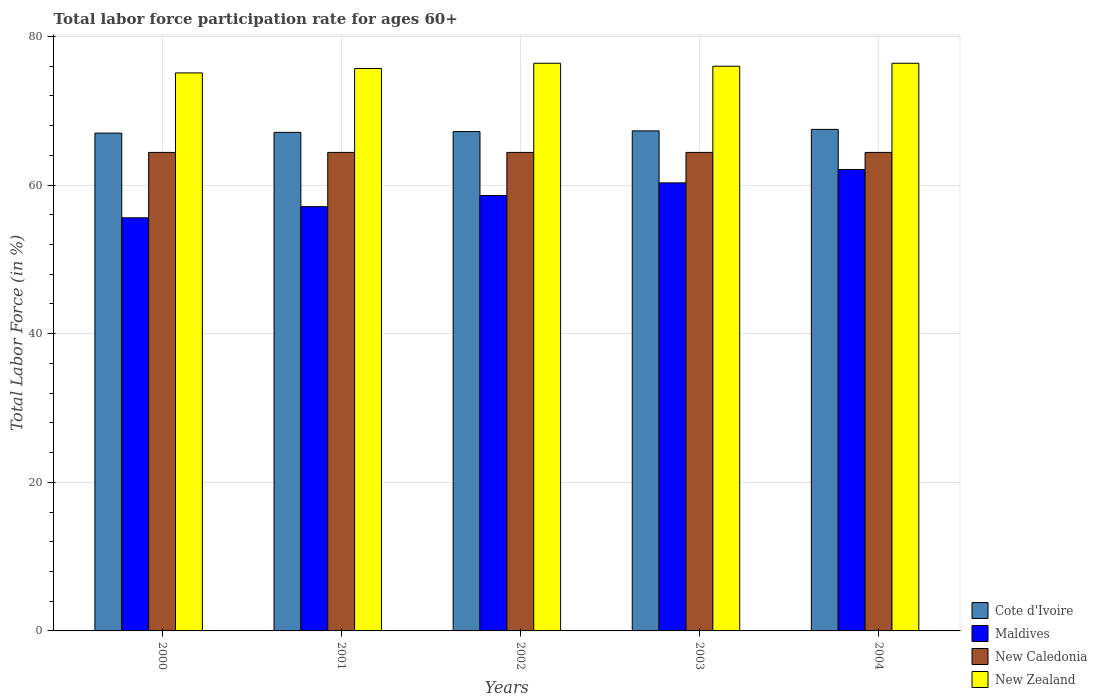Are the number of bars on each tick of the X-axis equal?
Ensure brevity in your answer.  Yes. How many bars are there on the 3rd tick from the left?
Offer a very short reply. 4. How many bars are there on the 1st tick from the right?
Offer a terse response. 4. In how many cases, is the number of bars for a given year not equal to the number of legend labels?
Provide a short and direct response. 0. What is the labor force participation rate in Cote d'Ivoire in 2004?
Offer a terse response. 67.5. Across all years, what is the maximum labor force participation rate in Cote d'Ivoire?
Your response must be concise. 67.5. Across all years, what is the minimum labor force participation rate in New Zealand?
Provide a short and direct response. 75.1. In which year was the labor force participation rate in New Zealand minimum?
Make the answer very short. 2000. What is the total labor force participation rate in Cote d'Ivoire in the graph?
Offer a very short reply. 336.1. What is the difference between the labor force participation rate in Cote d'Ivoire in 2000 and that in 2004?
Ensure brevity in your answer.  -0.5. What is the difference between the labor force participation rate in New Zealand in 2000 and the labor force participation rate in Maldives in 2003?
Make the answer very short. 14.8. What is the average labor force participation rate in Cote d'Ivoire per year?
Make the answer very short. 67.22. In the year 2002, what is the difference between the labor force participation rate in Maldives and labor force participation rate in New Zealand?
Offer a terse response. -17.8. In how many years, is the labor force participation rate in Maldives greater than 28 %?
Offer a very short reply. 5. What is the ratio of the labor force participation rate in Maldives in 2000 to that in 2004?
Provide a succinct answer. 0.9. Is the labor force participation rate in Cote d'Ivoire in 2001 less than that in 2004?
Offer a very short reply. Yes. Is the difference between the labor force participation rate in Maldives in 2000 and 2003 greater than the difference between the labor force participation rate in New Zealand in 2000 and 2003?
Provide a short and direct response. No. What is the difference between the highest and the second highest labor force participation rate in New Zealand?
Keep it short and to the point. 0. What is the difference between the highest and the lowest labor force participation rate in Maldives?
Your answer should be very brief. 6.5. In how many years, is the labor force participation rate in Cote d'Ivoire greater than the average labor force participation rate in Cote d'Ivoire taken over all years?
Ensure brevity in your answer.  2. Is it the case that in every year, the sum of the labor force participation rate in New Caledonia and labor force participation rate in Cote d'Ivoire is greater than the sum of labor force participation rate in Maldives and labor force participation rate in New Zealand?
Provide a short and direct response. No. What does the 2nd bar from the left in 2001 represents?
Provide a short and direct response. Maldives. What does the 2nd bar from the right in 2000 represents?
Your response must be concise. New Caledonia. Is it the case that in every year, the sum of the labor force participation rate in Maldives and labor force participation rate in New Caledonia is greater than the labor force participation rate in Cote d'Ivoire?
Your response must be concise. Yes. Are all the bars in the graph horizontal?
Your answer should be compact. No. How many years are there in the graph?
Your answer should be compact. 5. Does the graph contain any zero values?
Make the answer very short. No. Where does the legend appear in the graph?
Make the answer very short. Bottom right. How many legend labels are there?
Offer a terse response. 4. What is the title of the graph?
Your answer should be very brief. Total labor force participation rate for ages 60+. What is the label or title of the X-axis?
Make the answer very short. Years. What is the label or title of the Y-axis?
Make the answer very short. Total Labor Force (in %). What is the Total Labor Force (in %) in Maldives in 2000?
Give a very brief answer. 55.6. What is the Total Labor Force (in %) in New Caledonia in 2000?
Make the answer very short. 64.4. What is the Total Labor Force (in %) in New Zealand in 2000?
Make the answer very short. 75.1. What is the Total Labor Force (in %) of Cote d'Ivoire in 2001?
Offer a very short reply. 67.1. What is the Total Labor Force (in %) in Maldives in 2001?
Make the answer very short. 57.1. What is the Total Labor Force (in %) in New Caledonia in 2001?
Keep it short and to the point. 64.4. What is the Total Labor Force (in %) in New Zealand in 2001?
Make the answer very short. 75.7. What is the Total Labor Force (in %) in Cote d'Ivoire in 2002?
Your answer should be compact. 67.2. What is the Total Labor Force (in %) of Maldives in 2002?
Your answer should be very brief. 58.6. What is the Total Labor Force (in %) of New Caledonia in 2002?
Provide a short and direct response. 64.4. What is the Total Labor Force (in %) of New Zealand in 2002?
Your answer should be compact. 76.4. What is the Total Labor Force (in %) of Cote d'Ivoire in 2003?
Your answer should be compact. 67.3. What is the Total Labor Force (in %) of Maldives in 2003?
Keep it short and to the point. 60.3. What is the Total Labor Force (in %) in New Caledonia in 2003?
Offer a terse response. 64.4. What is the Total Labor Force (in %) of Cote d'Ivoire in 2004?
Offer a very short reply. 67.5. What is the Total Labor Force (in %) of Maldives in 2004?
Your response must be concise. 62.1. What is the Total Labor Force (in %) of New Caledonia in 2004?
Keep it short and to the point. 64.4. What is the Total Labor Force (in %) of New Zealand in 2004?
Your response must be concise. 76.4. Across all years, what is the maximum Total Labor Force (in %) in Cote d'Ivoire?
Your response must be concise. 67.5. Across all years, what is the maximum Total Labor Force (in %) of Maldives?
Offer a very short reply. 62.1. Across all years, what is the maximum Total Labor Force (in %) in New Caledonia?
Keep it short and to the point. 64.4. Across all years, what is the maximum Total Labor Force (in %) in New Zealand?
Your answer should be very brief. 76.4. Across all years, what is the minimum Total Labor Force (in %) in Cote d'Ivoire?
Your response must be concise. 67. Across all years, what is the minimum Total Labor Force (in %) in Maldives?
Your response must be concise. 55.6. Across all years, what is the minimum Total Labor Force (in %) of New Caledonia?
Offer a very short reply. 64.4. Across all years, what is the minimum Total Labor Force (in %) in New Zealand?
Your answer should be very brief. 75.1. What is the total Total Labor Force (in %) in Cote d'Ivoire in the graph?
Make the answer very short. 336.1. What is the total Total Labor Force (in %) of Maldives in the graph?
Provide a succinct answer. 293.7. What is the total Total Labor Force (in %) in New Caledonia in the graph?
Give a very brief answer. 322. What is the total Total Labor Force (in %) of New Zealand in the graph?
Offer a very short reply. 379.6. What is the difference between the Total Labor Force (in %) in Maldives in 2000 and that in 2001?
Give a very brief answer. -1.5. What is the difference between the Total Labor Force (in %) in New Caledonia in 2000 and that in 2001?
Provide a succinct answer. 0. What is the difference between the Total Labor Force (in %) in Cote d'Ivoire in 2000 and that in 2002?
Offer a very short reply. -0.2. What is the difference between the Total Labor Force (in %) in Maldives in 2000 and that in 2002?
Give a very brief answer. -3. What is the difference between the Total Labor Force (in %) of Cote d'Ivoire in 2000 and that in 2003?
Your answer should be compact. -0.3. What is the difference between the Total Labor Force (in %) of Maldives in 2000 and that in 2003?
Keep it short and to the point. -4.7. What is the difference between the Total Labor Force (in %) of Cote d'Ivoire in 2000 and that in 2004?
Provide a succinct answer. -0.5. What is the difference between the Total Labor Force (in %) in New Zealand in 2000 and that in 2004?
Provide a succinct answer. -1.3. What is the difference between the Total Labor Force (in %) of Cote d'Ivoire in 2001 and that in 2002?
Your response must be concise. -0.1. What is the difference between the Total Labor Force (in %) of New Caledonia in 2001 and that in 2002?
Offer a terse response. 0. What is the difference between the Total Labor Force (in %) of New Zealand in 2001 and that in 2002?
Ensure brevity in your answer.  -0.7. What is the difference between the Total Labor Force (in %) of Maldives in 2001 and that in 2003?
Your answer should be compact. -3.2. What is the difference between the Total Labor Force (in %) of Maldives in 2001 and that in 2004?
Offer a very short reply. -5. What is the difference between the Total Labor Force (in %) of Maldives in 2002 and that in 2003?
Provide a short and direct response. -1.7. What is the difference between the Total Labor Force (in %) of New Caledonia in 2002 and that in 2003?
Your answer should be very brief. 0. What is the difference between the Total Labor Force (in %) in New Zealand in 2002 and that in 2003?
Your answer should be compact. 0.4. What is the difference between the Total Labor Force (in %) of New Caledonia in 2002 and that in 2004?
Your response must be concise. 0. What is the difference between the Total Labor Force (in %) of Maldives in 2003 and that in 2004?
Ensure brevity in your answer.  -1.8. What is the difference between the Total Labor Force (in %) in New Zealand in 2003 and that in 2004?
Provide a succinct answer. -0.4. What is the difference between the Total Labor Force (in %) in Cote d'Ivoire in 2000 and the Total Labor Force (in %) in New Zealand in 2001?
Make the answer very short. -8.7. What is the difference between the Total Labor Force (in %) in Maldives in 2000 and the Total Labor Force (in %) in New Zealand in 2001?
Your response must be concise. -20.1. What is the difference between the Total Labor Force (in %) in Cote d'Ivoire in 2000 and the Total Labor Force (in %) in Maldives in 2002?
Offer a terse response. 8.4. What is the difference between the Total Labor Force (in %) of Cote d'Ivoire in 2000 and the Total Labor Force (in %) of New Caledonia in 2002?
Make the answer very short. 2.6. What is the difference between the Total Labor Force (in %) in Maldives in 2000 and the Total Labor Force (in %) in New Zealand in 2002?
Give a very brief answer. -20.8. What is the difference between the Total Labor Force (in %) of Cote d'Ivoire in 2000 and the Total Labor Force (in %) of Maldives in 2003?
Your answer should be compact. 6.7. What is the difference between the Total Labor Force (in %) in Cote d'Ivoire in 2000 and the Total Labor Force (in %) in New Caledonia in 2003?
Your answer should be compact. 2.6. What is the difference between the Total Labor Force (in %) in Maldives in 2000 and the Total Labor Force (in %) in New Zealand in 2003?
Provide a short and direct response. -20.4. What is the difference between the Total Labor Force (in %) of Cote d'Ivoire in 2000 and the Total Labor Force (in %) of Maldives in 2004?
Your response must be concise. 4.9. What is the difference between the Total Labor Force (in %) in Cote d'Ivoire in 2000 and the Total Labor Force (in %) in New Caledonia in 2004?
Offer a very short reply. 2.6. What is the difference between the Total Labor Force (in %) in Maldives in 2000 and the Total Labor Force (in %) in New Caledonia in 2004?
Your answer should be compact. -8.8. What is the difference between the Total Labor Force (in %) of Maldives in 2000 and the Total Labor Force (in %) of New Zealand in 2004?
Your response must be concise. -20.8. What is the difference between the Total Labor Force (in %) of Cote d'Ivoire in 2001 and the Total Labor Force (in %) of Maldives in 2002?
Make the answer very short. 8.5. What is the difference between the Total Labor Force (in %) of Cote d'Ivoire in 2001 and the Total Labor Force (in %) of New Zealand in 2002?
Offer a terse response. -9.3. What is the difference between the Total Labor Force (in %) in Maldives in 2001 and the Total Labor Force (in %) in New Caledonia in 2002?
Make the answer very short. -7.3. What is the difference between the Total Labor Force (in %) of Maldives in 2001 and the Total Labor Force (in %) of New Zealand in 2002?
Your answer should be very brief. -19.3. What is the difference between the Total Labor Force (in %) in New Caledonia in 2001 and the Total Labor Force (in %) in New Zealand in 2002?
Keep it short and to the point. -12. What is the difference between the Total Labor Force (in %) in Cote d'Ivoire in 2001 and the Total Labor Force (in %) in Maldives in 2003?
Your response must be concise. 6.8. What is the difference between the Total Labor Force (in %) of Cote d'Ivoire in 2001 and the Total Labor Force (in %) of New Caledonia in 2003?
Your answer should be compact. 2.7. What is the difference between the Total Labor Force (in %) of Cote d'Ivoire in 2001 and the Total Labor Force (in %) of New Zealand in 2003?
Ensure brevity in your answer.  -8.9. What is the difference between the Total Labor Force (in %) in Maldives in 2001 and the Total Labor Force (in %) in New Caledonia in 2003?
Offer a very short reply. -7.3. What is the difference between the Total Labor Force (in %) in Maldives in 2001 and the Total Labor Force (in %) in New Zealand in 2003?
Offer a terse response. -18.9. What is the difference between the Total Labor Force (in %) of Cote d'Ivoire in 2001 and the Total Labor Force (in %) of Maldives in 2004?
Offer a terse response. 5. What is the difference between the Total Labor Force (in %) in Cote d'Ivoire in 2001 and the Total Labor Force (in %) in New Zealand in 2004?
Provide a short and direct response. -9.3. What is the difference between the Total Labor Force (in %) of Maldives in 2001 and the Total Labor Force (in %) of New Zealand in 2004?
Make the answer very short. -19.3. What is the difference between the Total Labor Force (in %) in New Caledonia in 2001 and the Total Labor Force (in %) in New Zealand in 2004?
Ensure brevity in your answer.  -12. What is the difference between the Total Labor Force (in %) in Cote d'Ivoire in 2002 and the Total Labor Force (in %) in New Caledonia in 2003?
Your answer should be very brief. 2.8. What is the difference between the Total Labor Force (in %) in Cote d'Ivoire in 2002 and the Total Labor Force (in %) in New Zealand in 2003?
Offer a very short reply. -8.8. What is the difference between the Total Labor Force (in %) of Maldives in 2002 and the Total Labor Force (in %) of New Caledonia in 2003?
Keep it short and to the point. -5.8. What is the difference between the Total Labor Force (in %) in Maldives in 2002 and the Total Labor Force (in %) in New Zealand in 2003?
Keep it short and to the point. -17.4. What is the difference between the Total Labor Force (in %) in Cote d'Ivoire in 2002 and the Total Labor Force (in %) in Maldives in 2004?
Make the answer very short. 5.1. What is the difference between the Total Labor Force (in %) in Cote d'Ivoire in 2002 and the Total Labor Force (in %) in New Caledonia in 2004?
Ensure brevity in your answer.  2.8. What is the difference between the Total Labor Force (in %) of Cote d'Ivoire in 2002 and the Total Labor Force (in %) of New Zealand in 2004?
Your answer should be very brief. -9.2. What is the difference between the Total Labor Force (in %) of Maldives in 2002 and the Total Labor Force (in %) of New Caledonia in 2004?
Keep it short and to the point. -5.8. What is the difference between the Total Labor Force (in %) in Maldives in 2002 and the Total Labor Force (in %) in New Zealand in 2004?
Offer a very short reply. -17.8. What is the difference between the Total Labor Force (in %) in New Caledonia in 2002 and the Total Labor Force (in %) in New Zealand in 2004?
Provide a succinct answer. -12. What is the difference between the Total Labor Force (in %) of Cote d'Ivoire in 2003 and the Total Labor Force (in %) of Maldives in 2004?
Provide a short and direct response. 5.2. What is the difference between the Total Labor Force (in %) in Cote d'Ivoire in 2003 and the Total Labor Force (in %) in New Zealand in 2004?
Your answer should be compact. -9.1. What is the difference between the Total Labor Force (in %) in Maldives in 2003 and the Total Labor Force (in %) in New Zealand in 2004?
Offer a very short reply. -16.1. What is the difference between the Total Labor Force (in %) in New Caledonia in 2003 and the Total Labor Force (in %) in New Zealand in 2004?
Provide a succinct answer. -12. What is the average Total Labor Force (in %) of Cote d'Ivoire per year?
Give a very brief answer. 67.22. What is the average Total Labor Force (in %) in Maldives per year?
Give a very brief answer. 58.74. What is the average Total Labor Force (in %) of New Caledonia per year?
Offer a terse response. 64.4. What is the average Total Labor Force (in %) in New Zealand per year?
Ensure brevity in your answer.  75.92. In the year 2000, what is the difference between the Total Labor Force (in %) of Cote d'Ivoire and Total Labor Force (in %) of New Caledonia?
Your answer should be compact. 2.6. In the year 2000, what is the difference between the Total Labor Force (in %) of Cote d'Ivoire and Total Labor Force (in %) of New Zealand?
Provide a short and direct response. -8.1. In the year 2000, what is the difference between the Total Labor Force (in %) of Maldives and Total Labor Force (in %) of New Caledonia?
Offer a very short reply. -8.8. In the year 2000, what is the difference between the Total Labor Force (in %) in Maldives and Total Labor Force (in %) in New Zealand?
Offer a very short reply. -19.5. In the year 2000, what is the difference between the Total Labor Force (in %) of New Caledonia and Total Labor Force (in %) of New Zealand?
Keep it short and to the point. -10.7. In the year 2001, what is the difference between the Total Labor Force (in %) in Cote d'Ivoire and Total Labor Force (in %) in Maldives?
Offer a terse response. 10. In the year 2001, what is the difference between the Total Labor Force (in %) of Cote d'Ivoire and Total Labor Force (in %) of New Zealand?
Ensure brevity in your answer.  -8.6. In the year 2001, what is the difference between the Total Labor Force (in %) of Maldives and Total Labor Force (in %) of New Zealand?
Make the answer very short. -18.6. In the year 2002, what is the difference between the Total Labor Force (in %) in Cote d'Ivoire and Total Labor Force (in %) in Maldives?
Give a very brief answer. 8.6. In the year 2002, what is the difference between the Total Labor Force (in %) in Cote d'Ivoire and Total Labor Force (in %) in New Caledonia?
Provide a short and direct response. 2.8. In the year 2002, what is the difference between the Total Labor Force (in %) in Cote d'Ivoire and Total Labor Force (in %) in New Zealand?
Ensure brevity in your answer.  -9.2. In the year 2002, what is the difference between the Total Labor Force (in %) of Maldives and Total Labor Force (in %) of New Caledonia?
Your response must be concise. -5.8. In the year 2002, what is the difference between the Total Labor Force (in %) of Maldives and Total Labor Force (in %) of New Zealand?
Your response must be concise. -17.8. In the year 2002, what is the difference between the Total Labor Force (in %) in New Caledonia and Total Labor Force (in %) in New Zealand?
Your answer should be compact. -12. In the year 2003, what is the difference between the Total Labor Force (in %) in Cote d'Ivoire and Total Labor Force (in %) in Maldives?
Offer a very short reply. 7. In the year 2003, what is the difference between the Total Labor Force (in %) of Maldives and Total Labor Force (in %) of New Zealand?
Give a very brief answer. -15.7. In the year 2004, what is the difference between the Total Labor Force (in %) of Cote d'Ivoire and Total Labor Force (in %) of Maldives?
Your response must be concise. 5.4. In the year 2004, what is the difference between the Total Labor Force (in %) in Maldives and Total Labor Force (in %) in New Zealand?
Your response must be concise. -14.3. What is the ratio of the Total Labor Force (in %) in Maldives in 2000 to that in 2001?
Offer a very short reply. 0.97. What is the ratio of the Total Labor Force (in %) of Maldives in 2000 to that in 2002?
Your response must be concise. 0.95. What is the ratio of the Total Labor Force (in %) in New Caledonia in 2000 to that in 2002?
Provide a succinct answer. 1. What is the ratio of the Total Labor Force (in %) in Maldives in 2000 to that in 2003?
Provide a short and direct response. 0.92. What is the ratio of the Total Labor Force (in %) in New Caledonia in 2000 to that in 2003?
Your answer should be compact. 1. What is the ratio of the Total Labor Force (in %) of Maldives in 2000 to that in 2004?
Make the answer very short. 0.9. What is the ratio of the Total Labor Force (in %) in New Caledonia in 2000 to that in 2004?
Your response must be concise. 1. What is the ratio of the Total Labor Force (in %) of New Zealand in 2000 to that in 2004?
Provide a succinct answer. 0.98. What is the ratio of the Total Labor Force (in %) in Cote d'Ivoire in 2001 to that in 2002?
Ensure brevity in your answer.  1. What is the ratio of the Total Labor Force (in %) of Maldives in 2001 to that in 2002?
Offer a terse response. 0.97. What is the ratio of the Total Labor Force (in %) of New Caledonia in 2001 to that in 2002?
Offer a very short reply. 1. What is the ratio of the Total Labor Force (in %) in Maldives in 2001 to that in 2003?
Keep it short and to the point. 0.95. What is the ratio of the Total Labor Force (in %) in New Caledonia in 2001 to that in 2003?
Keep it short and to the point. 1. What is the ratio of the Total Labor Force (in %) in Maldives in 2001 to that in 2004?
Make the answer very short. 0.92. What is the ratio of the Total Labor Force (in %) of New Caledonia in 2001 to that in 2004?
Provide a short and direct response. 1. What is the ratio of the Total Labor Force (in %) in Cote d'Ivoire in 2002 to that in 2003?
Make the answer very short. 1. What is the ratio of the Total Labor Force (in %) of Maldives in 2002 to that in 2003?
Provide a short and direct response. 0.97. What is the ratio of the Total Labor Force (in %) of New Zealand in 2002 to that in 2003?
Provide a short and direct response. 1.01. What is the ratio of the Total Labor Force (in %) of Maldives in 2002 to that in 2004?
Ensure brevity in your answer.  0.94. What is the ratio of the Total Labor Force (in %) in New Zealand in 2002 to that in 2004?
Offer a very short reply. 1. What is the ratio of the Total Labor Force (in %) in Cote d'Ivoire in 2003 to that in 2004?
Your response must be concise. 1. What is the ratio of the Total Labor Force (in %) in Maldives in 2003 to that in 2004?
Your response must be concise. 0.97. What is the ratio of the Total Labor Force (in %) of New Zealand in 2003 to that in 2004?
Ensure brevity in your answer.  0.99. What is the difference between the highest and the lowest Total Labor Force (in %) of Cote d'Ivoire?
Make the answer very short. 0.5. 